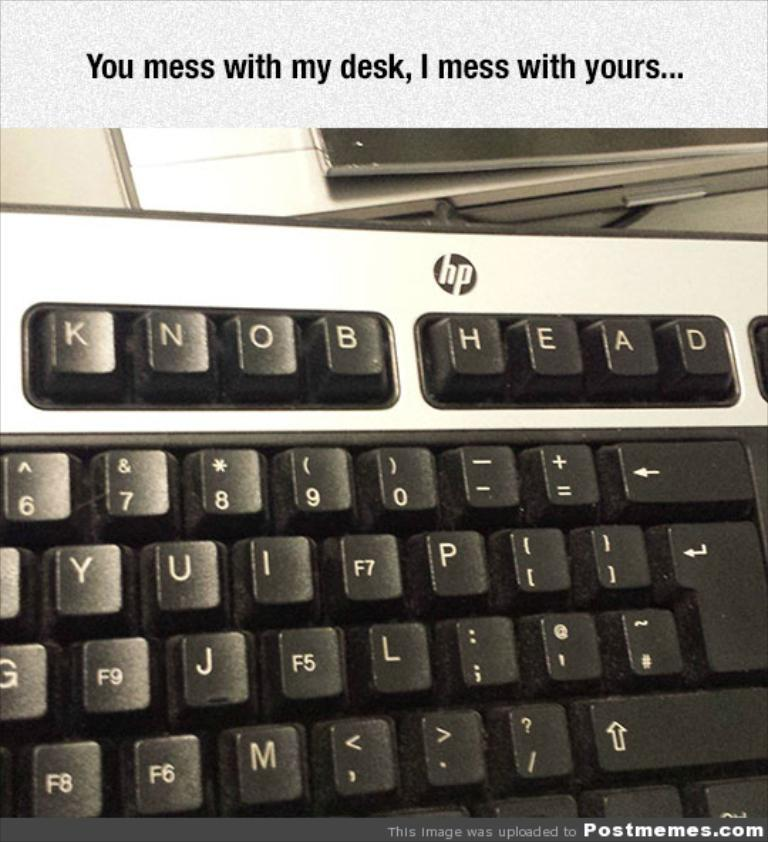<image>
Describe the image concisely. an HP keyboard with the buttons changed to KNOB head at the top 